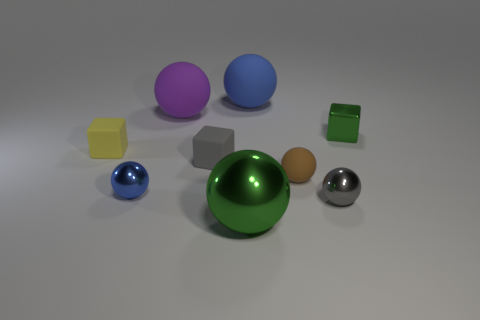Subtract all small gray metal balls. How many balls are left? 5 Subtract all red cubes. How many blue spheres are left? 2 Subtract all spheres. How many objects are left? 3 Subtract all green cubes. How many cubes are left? 2 Subtract 1 yellow cubes. How many objects are left? 8 Subtract 2 spheres. How many spheres are left? 4 Subtract all cyan balls. Subtract all red blocks. How many balls are left? 6 Subtract all tiny purple matte cylinders. Subtract all small blue balls. How many objects are left? 8 Add 6 big matte balls. How many big matte balls are left? 8 Add 6 green metallic balls. How many green metallic balls exist? 7 